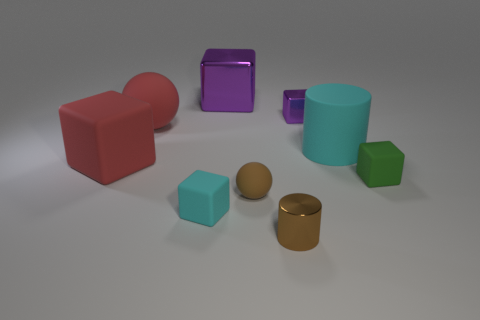Subtract all balls. How many objects are left? 7 Add 2 brown rubber spheres. How many brown rubber spheres exist? 3 Add 1 shiny cylinders. How many objects exist? 10 Subtract all brown balls. How many balls are left? 1 Subtract all large shiny blocks. How many blocks are left? 4 Subtract 0 green spheres. How many objects are left? 9 Subtract 1 balls. How many balls are left? 1 Subtract all purple cylinders. Subtract all brown balls. How many cylinders are left? 2 Subtract all purple cubes. How many brown spheres are left? 1 Subtract all small blue shiny balls. Subtract all rubber cylinders. How many objects are left? 8 